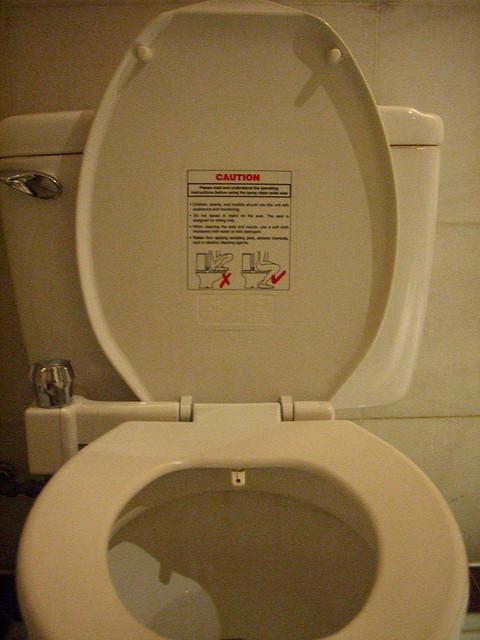How many legs does the man with the racket have?
Give a very brief answer. 0. 